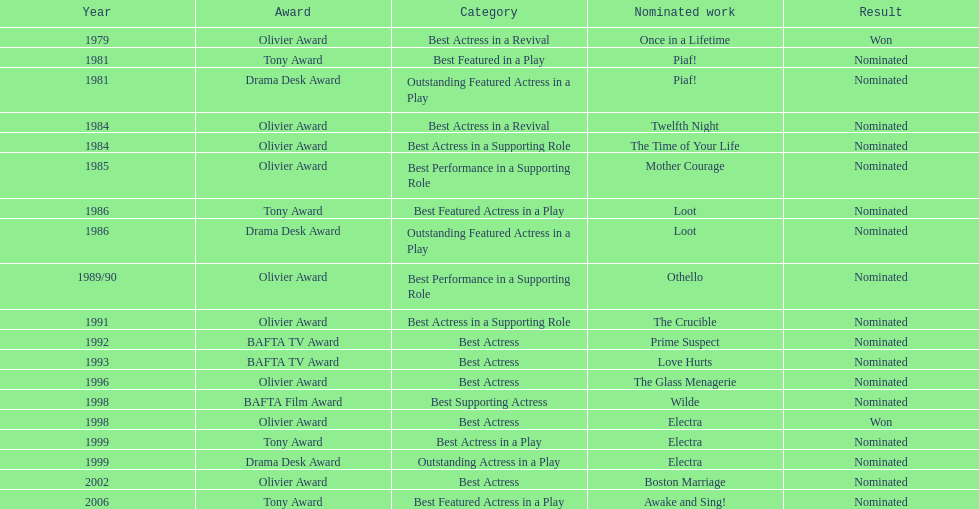In which year was prime suspects nominated for the bafta tv award? 1992. 